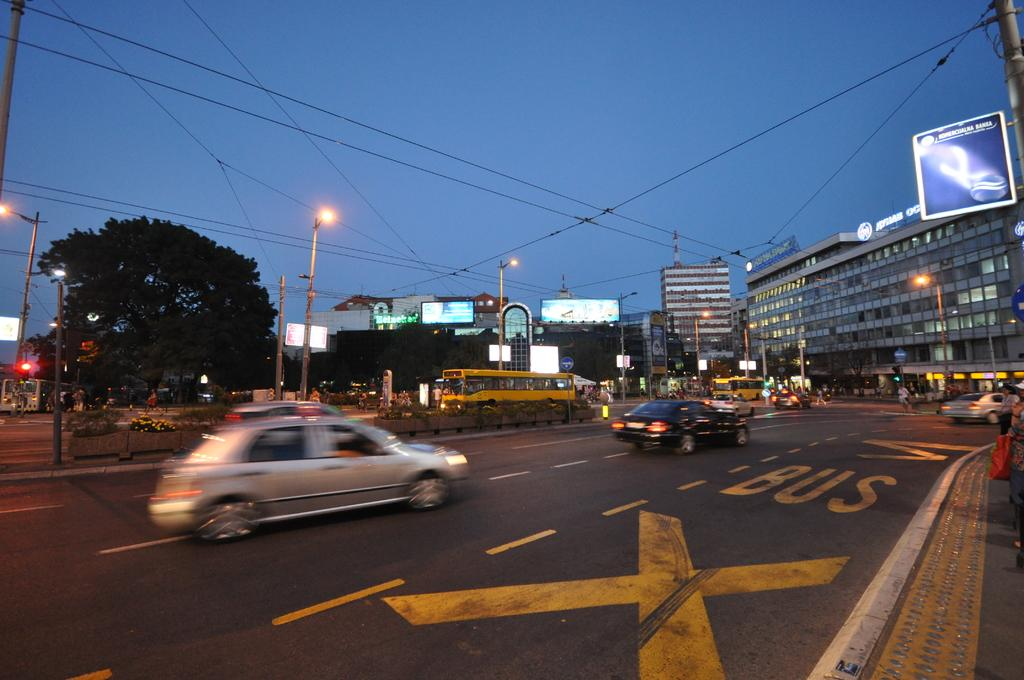<image>
Create a compact narrative representing the image presented. A silver car is nearing an intersection and passing a lane that says Bus. 